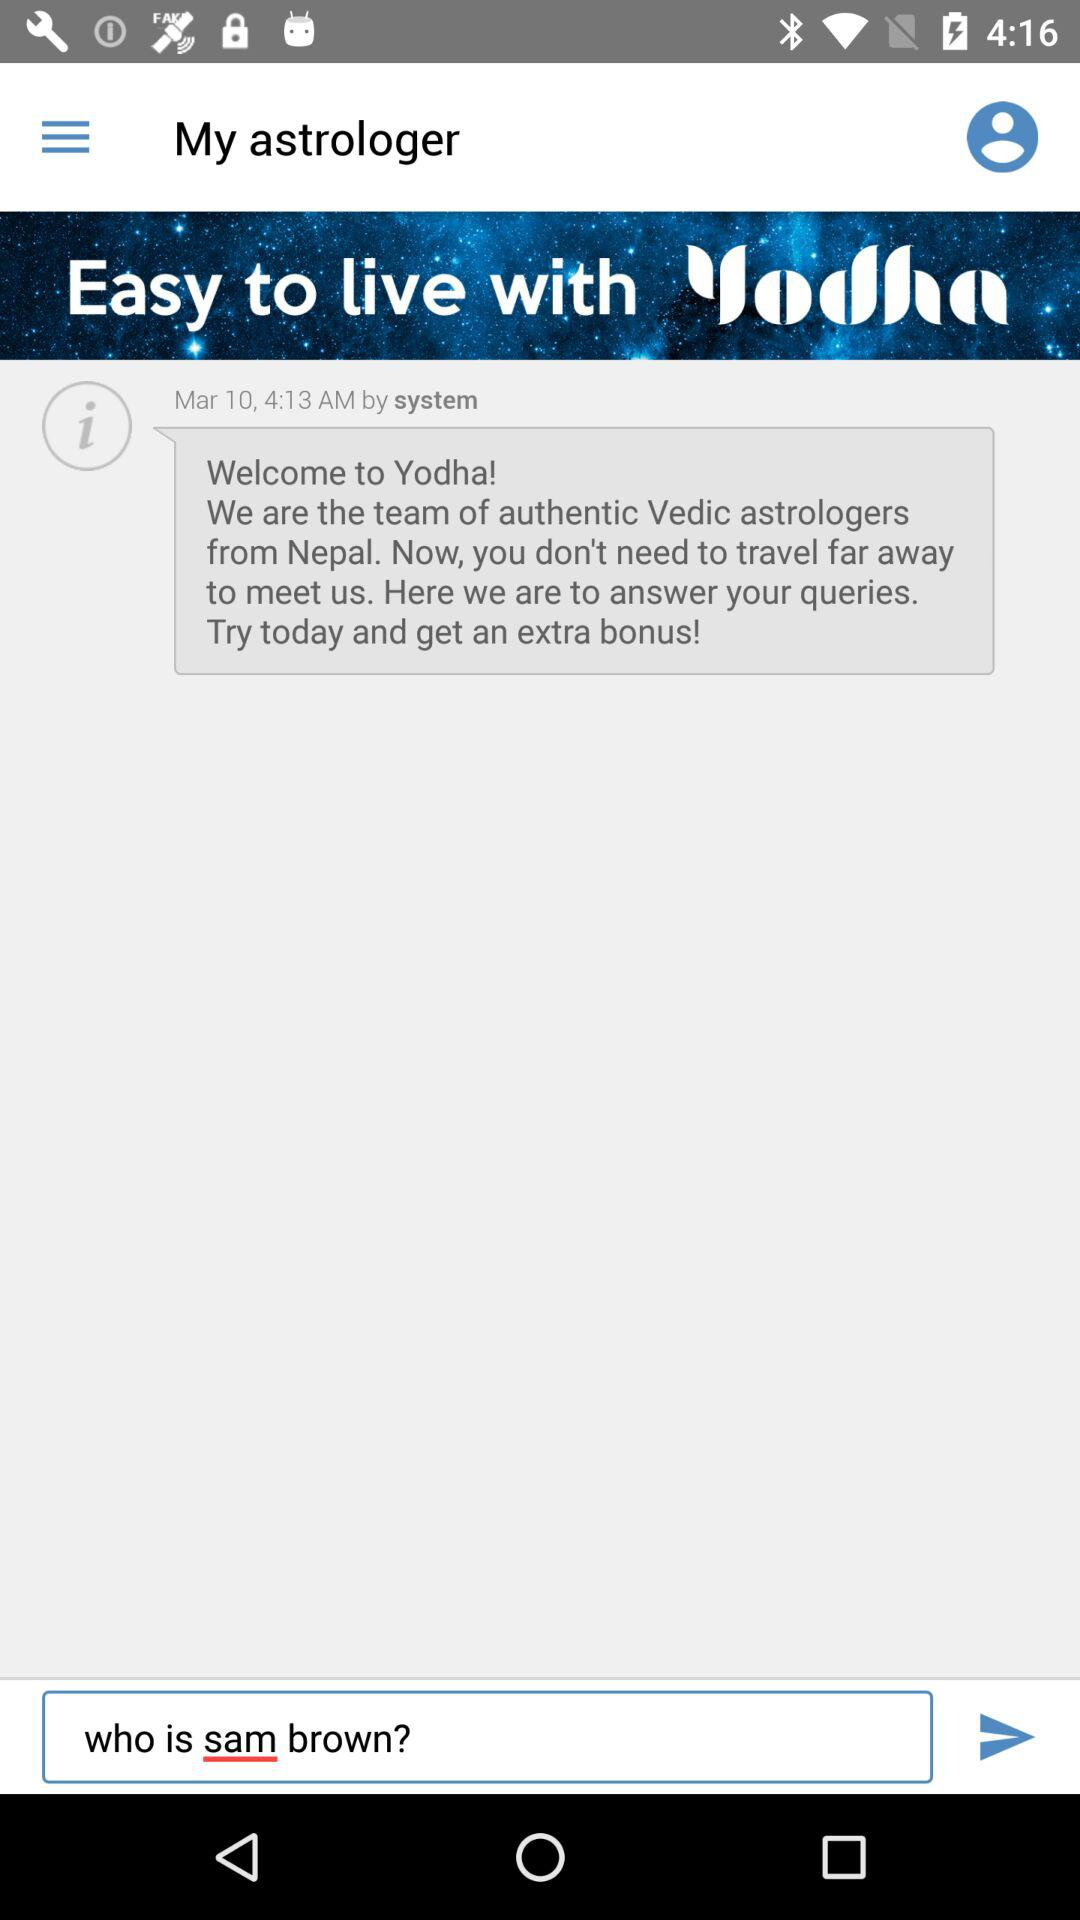What country is the team of authentic Vedic astrologers from? The team of authentic Vedic astrologers is from Nepal. 